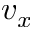Convert formula to latex. <formula><loc_0><loc_0><loc_500><loc_500>v _ { x }</formula> 